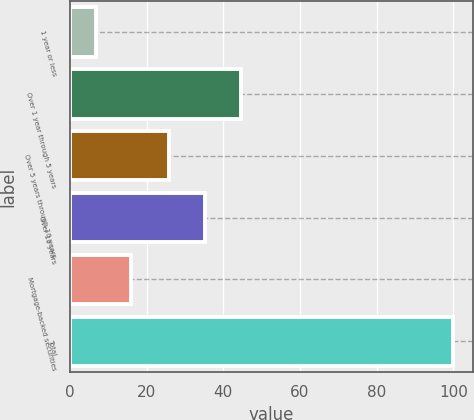Convert chart. <chart><loc_0><loc_0><loc_500><loc_500><bar_chart><fcel>1 year or less<fcel>Over 1 year through 5 years<fcel>Over 5 years through 10 years<fcel>Over 10 years<fcel>Mortgage-backed securities<fcel>Total<nl><fcel>6.7<fcel>44.56<fcel>25.9<fcel>35.23<fcel>16.03<fcel>100<nl></chart> 